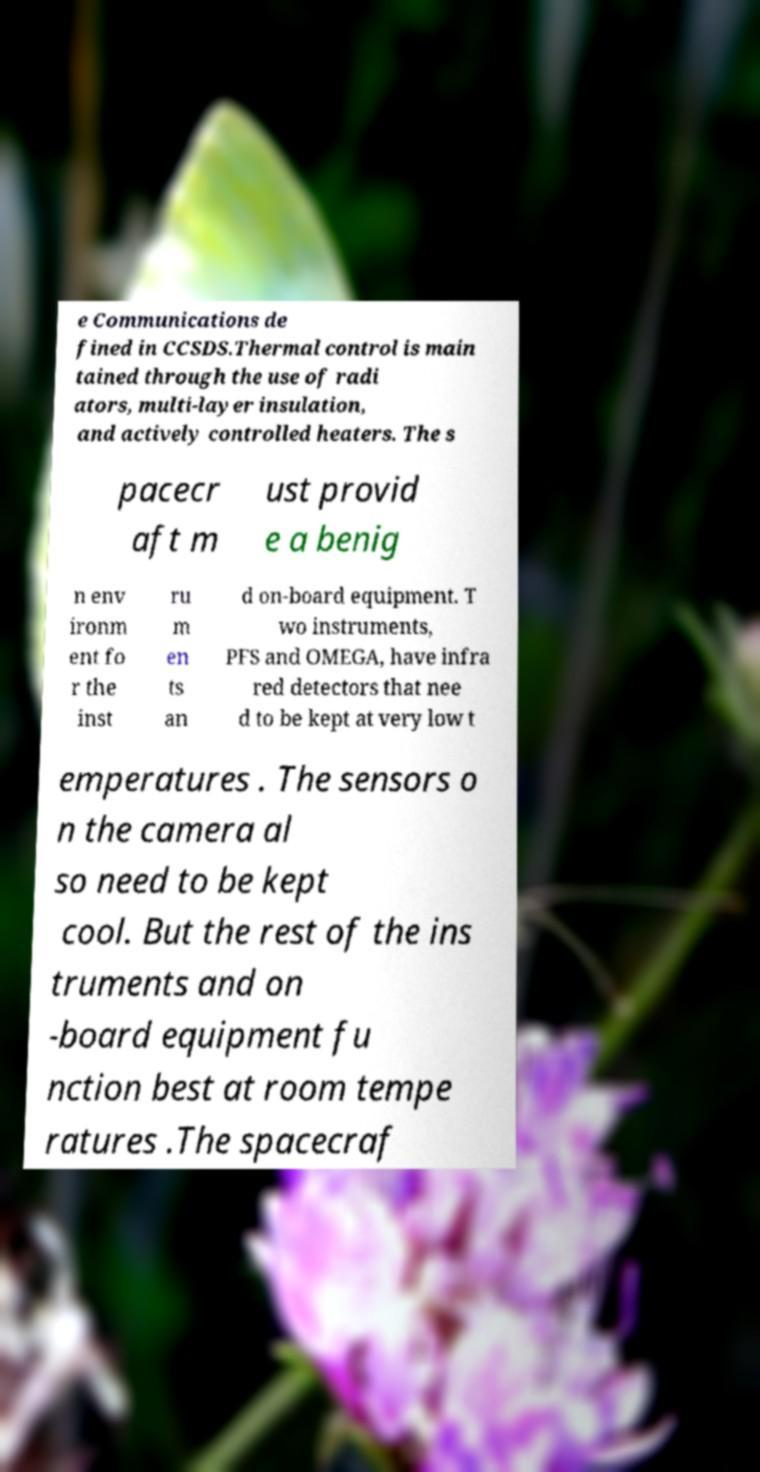What messages or text are displayed in this image? I need them in a readable, typed format. e Communications de fined in CCSDS.Thermal control is main tained through the use of radi ators, multi-layer insulation, and actively controlled heaters. The s pacecr aft m ust provid e a benig n env ironm ent fo r the inst ru m en ts an d on-board equipment. T wo instruments, PFS and OMEGA, have infra red detectors that nee d to be kept at very low t emperatures . The sensors o n the camera al so need to be kept cool. But the rest of the ins truments and on -board equipment fu nction best at room tempe ratures .The spacecraf 